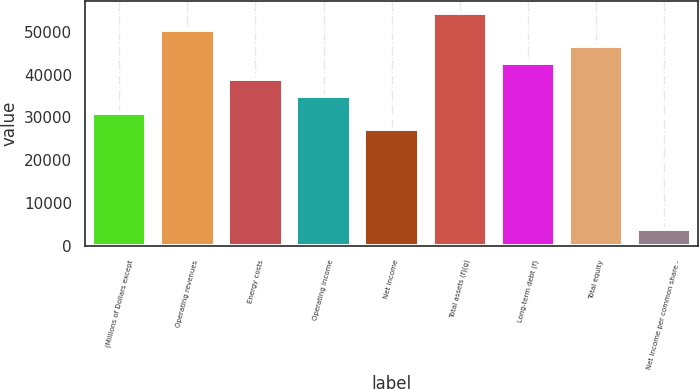<chart> <loc_0><loc_0><loc_500><loc_500><bar_chart><fcel>(Millions of Dollars except<fcel>Operating revenues<fcel>Energy costs<fcel>Operating income<fcel>Net income<fcel>Total assets (f)(g)<fcel>Long-term debt (f)<fcel>Total equity<fcel>Net Income per common share -<nl><fcel>31098.9<fcel>50534.2<fcel>38873<fcel>34985.9<fcel>27211.8<fcel>54421.2<fcel>42760.1<fcel>46647.1<fcel>3889.46<nl></chart> 